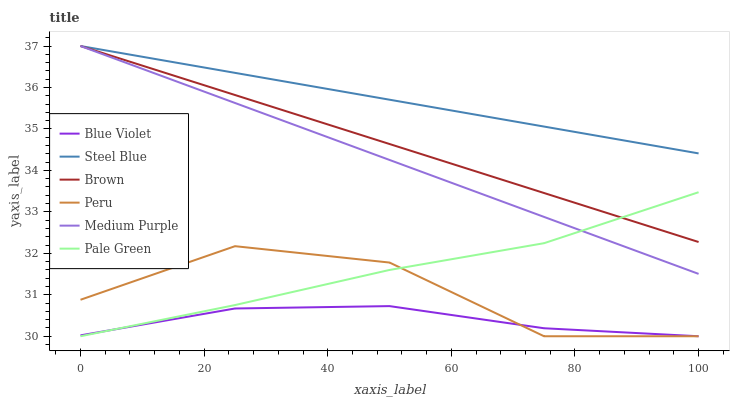Does Blue Violet have the minimum area under the curve?
Answer yes or no. Yes. Does Steel Blue have the maximum area under the curve?
Answer yes or no. Yes. Does Medium Purple have the minimum area under the curve?
Answer yes or no. No. Does Medium Purple have the maximum area under the curve?
Answer yes or no. No. Is Medium Purple the smoothest?
Answer yes or no. Yes. Is Peru the roughest?
Answer yes or no. Yes. Is Steel Blue the smoothest?
Answer yes or no. No. Is Steel Blue the roughest?
Answer yes or no. No. Does Medium Purple have the lowest value?
Answer yes or no. No. Does Medium Purple have the highest value?
Answer yes or no. Yes. Does Pale Green have the highest value?
Answer yes or no. No. Is Pale Green less than Steel Blue?
Answer yes or no. Yes. Is Brown greater than Peru?
Answer yes or no. Yes. Does Pale Green intersect Steel Blue?
Answer yes or no. No. 